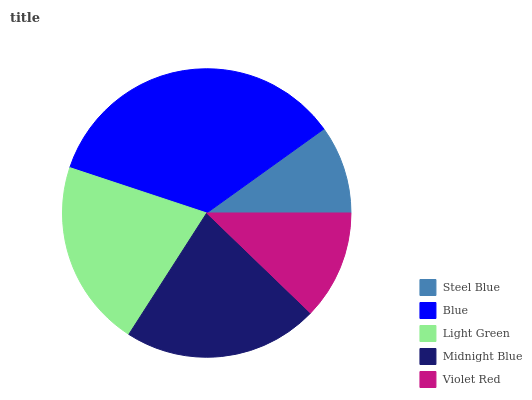Is Steel Blue the minimum?
Answer yes or no. Yes. Is Blue the maximum?
Answer yes or no. Yes. Is Light Green the minimum?
Answer yes or no. No. Is Light Green the maximum?
Answer yes or no. No. Is Blue greater than Light Green?
Answer yes or no. Yes. Is Light Green less than Blue?
Answer yes or no. Yes. Is Light Green greater than Blue?
Answer yes or no. No. Is Blue less than Light Green?
Answer yes or no. No. Is Light Green the high median?
Answer yes or no. Yes. Is Light Green the low median?
Answer yes or no. Yes. Is Blue the high median?
Answer yes or no. No. Is Blue the low median?
Answer yes or no. No. 